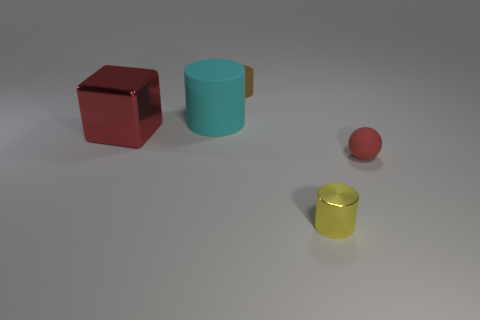Add 2 large cyan cylinders. How many objects exist? 7 Subtract all cylinders. How many objects are left? 2 Subtract 1 cyan cylinders. How many objects are left? 4 Subtract all blue objects. Subtract all big red blocks. How many objects are left? 4 Add 4 small rubber spheres. How many small rubber spheres are left? 5 Add 5 small brown matte cylinders. How many small brown matte cylinders exist? 6 